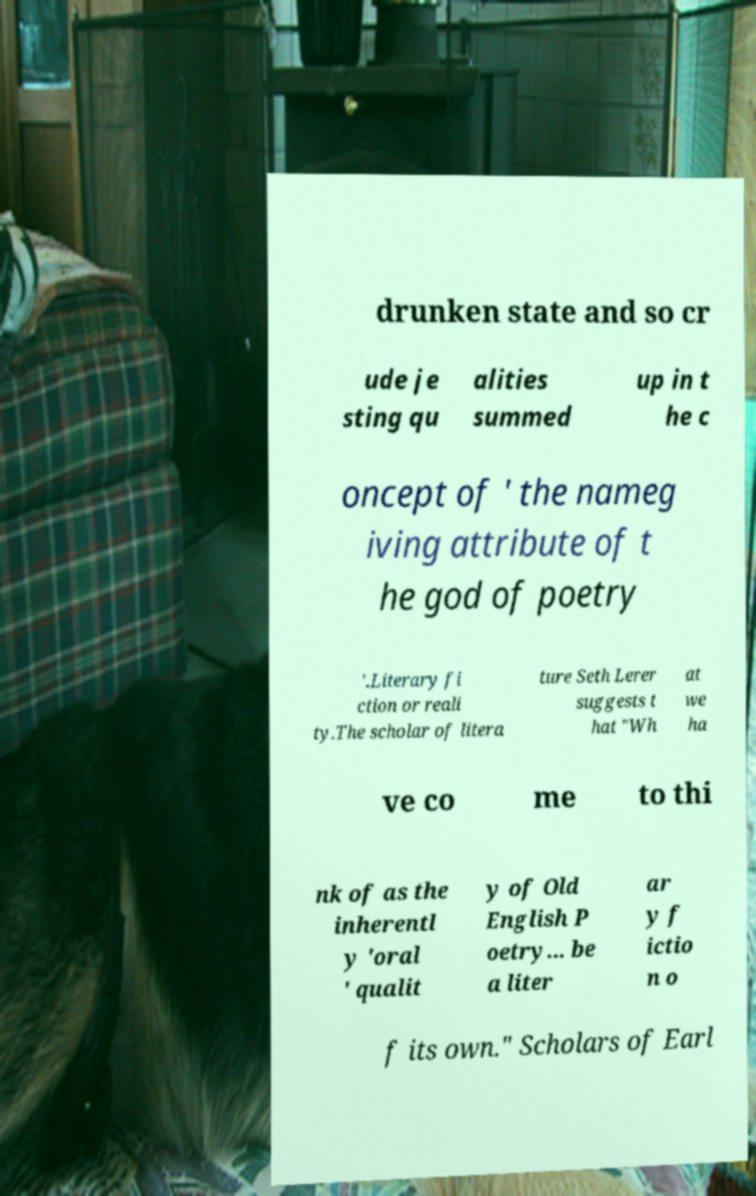Please read and relay the text visible in this image. What does it say? drunken state and so cr ude je sting qu alities summed up in t he c oncept of ' the nameg iving attribute of t he god of poetry '.Literary fi ction or reali ty.The scholar of litera ture Seth Lerer suggests t hat "Wh at we ha ve co me to thi nk of as the inherentl y 'oral ' qualit y of Old English P oetry... be a liter ar y f ictio n o f its own." Scholars of Earl 